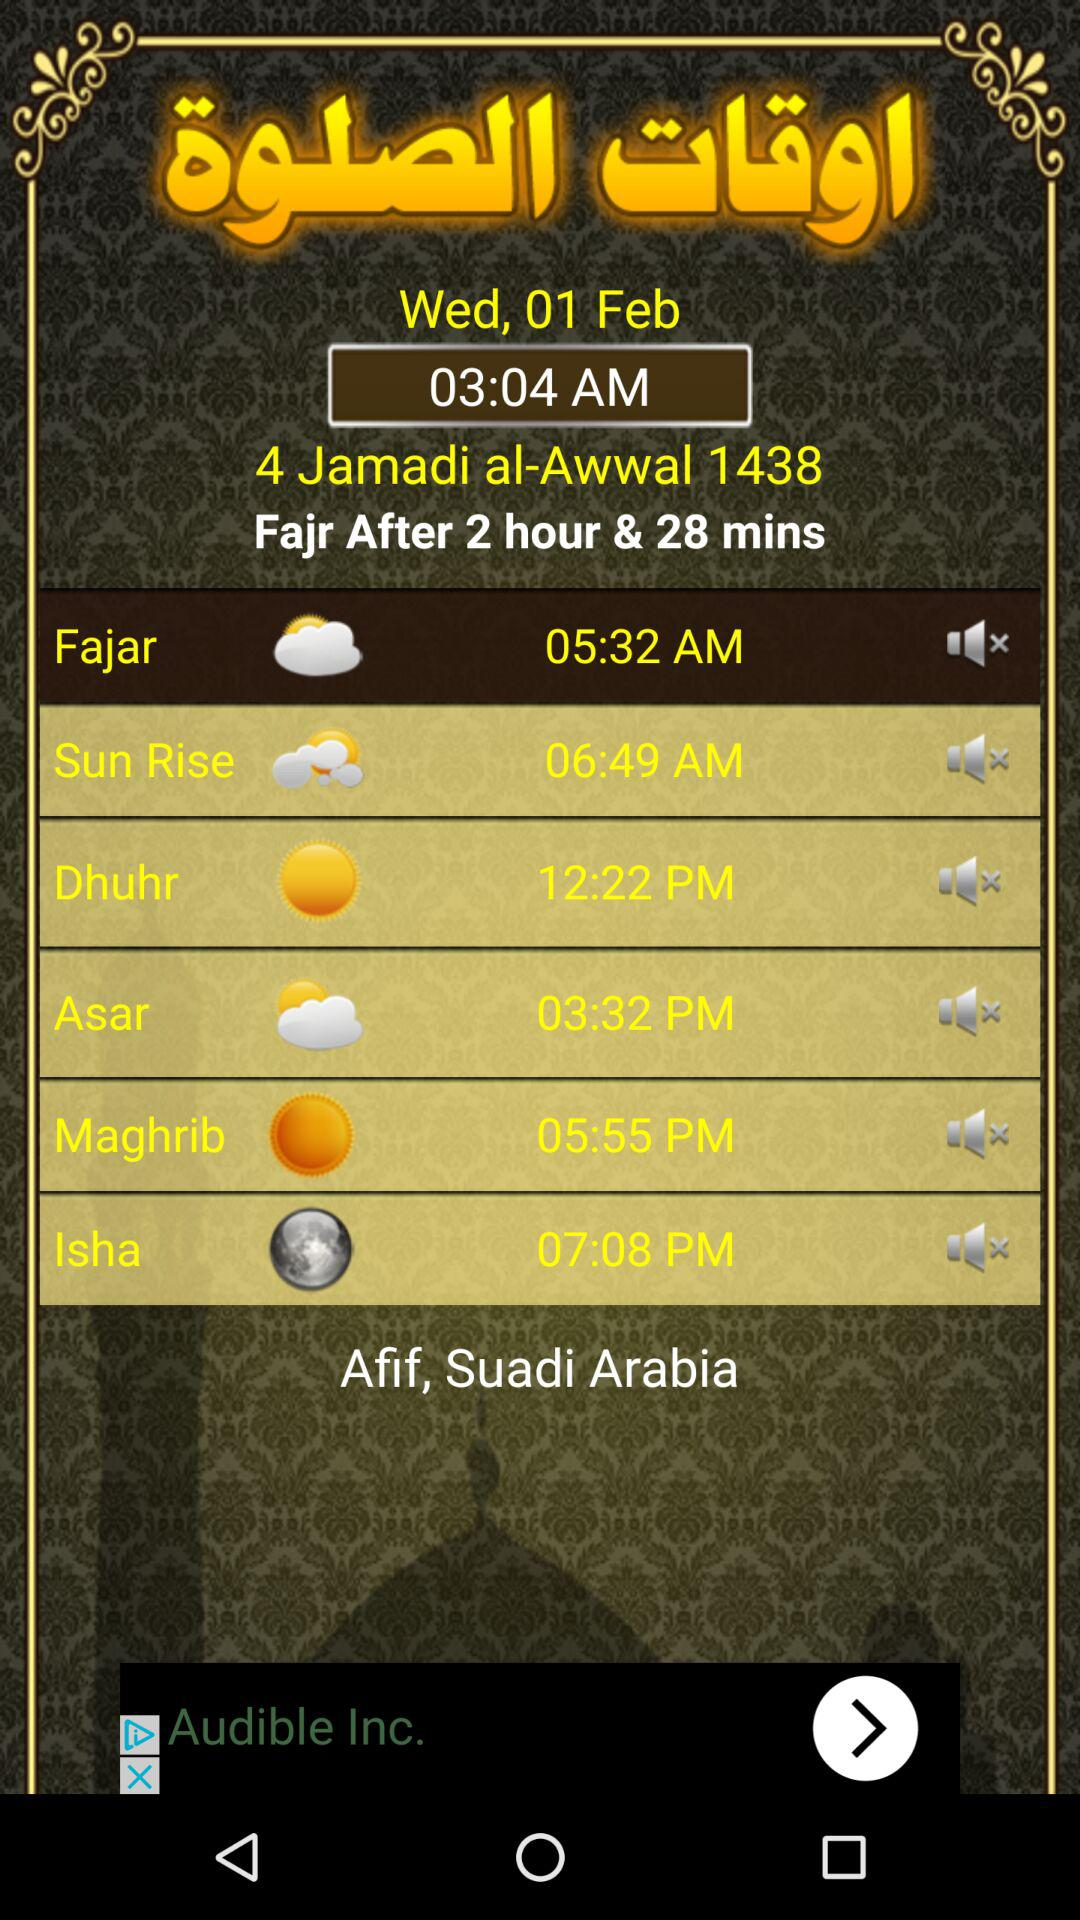What is the time for "Isha"? The time for "Isha" is 07:08 PM. 